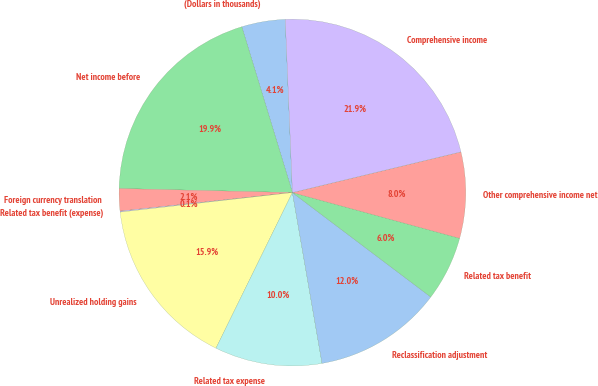Convert chart. <chart><loc_0><loc_0><loc_500><loc_500><pie_chart><fcel>(Dollars in thousands)<fcel>Net income before<fcel>Foreign currency translation<fcel>Related tax benefit (expense)<fcel>Unrealized holding gains<fcel>Related tax expense<fcel>Reclassification adjustment<fcel>Related tax benefit<fcel>Other comprehensive income net<fcel>Comprehensive income<nl><fcel>4.06%<fcel>19.91%<fcel>2.08%<fcel>0.09%<fcel>15.94%<fcel>10.0%<fcel>11.98%<fcel>6.04%<fcel>8.02%<fcel>21.89%<nl></chart> 